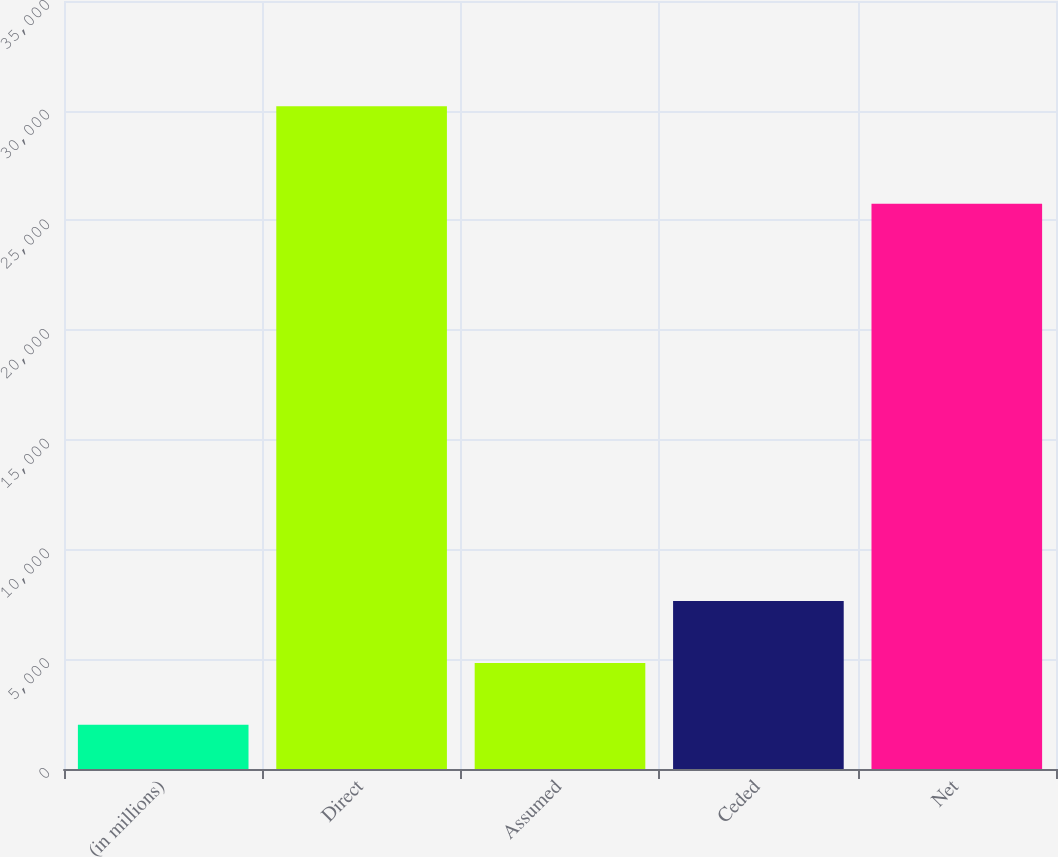Convert chart to OTSL. <chart><loc_0><loc_0><loc_500><loc_500><bar_chart><fcel>(in millions)<fcel>Direct<fcel>Assumed<fcel>Ceded<fcel>Net<nl><fcel>2017<fcel>30205<fcel>4835.8<fcel>7654.6<fcel>25756<nl></chart> 